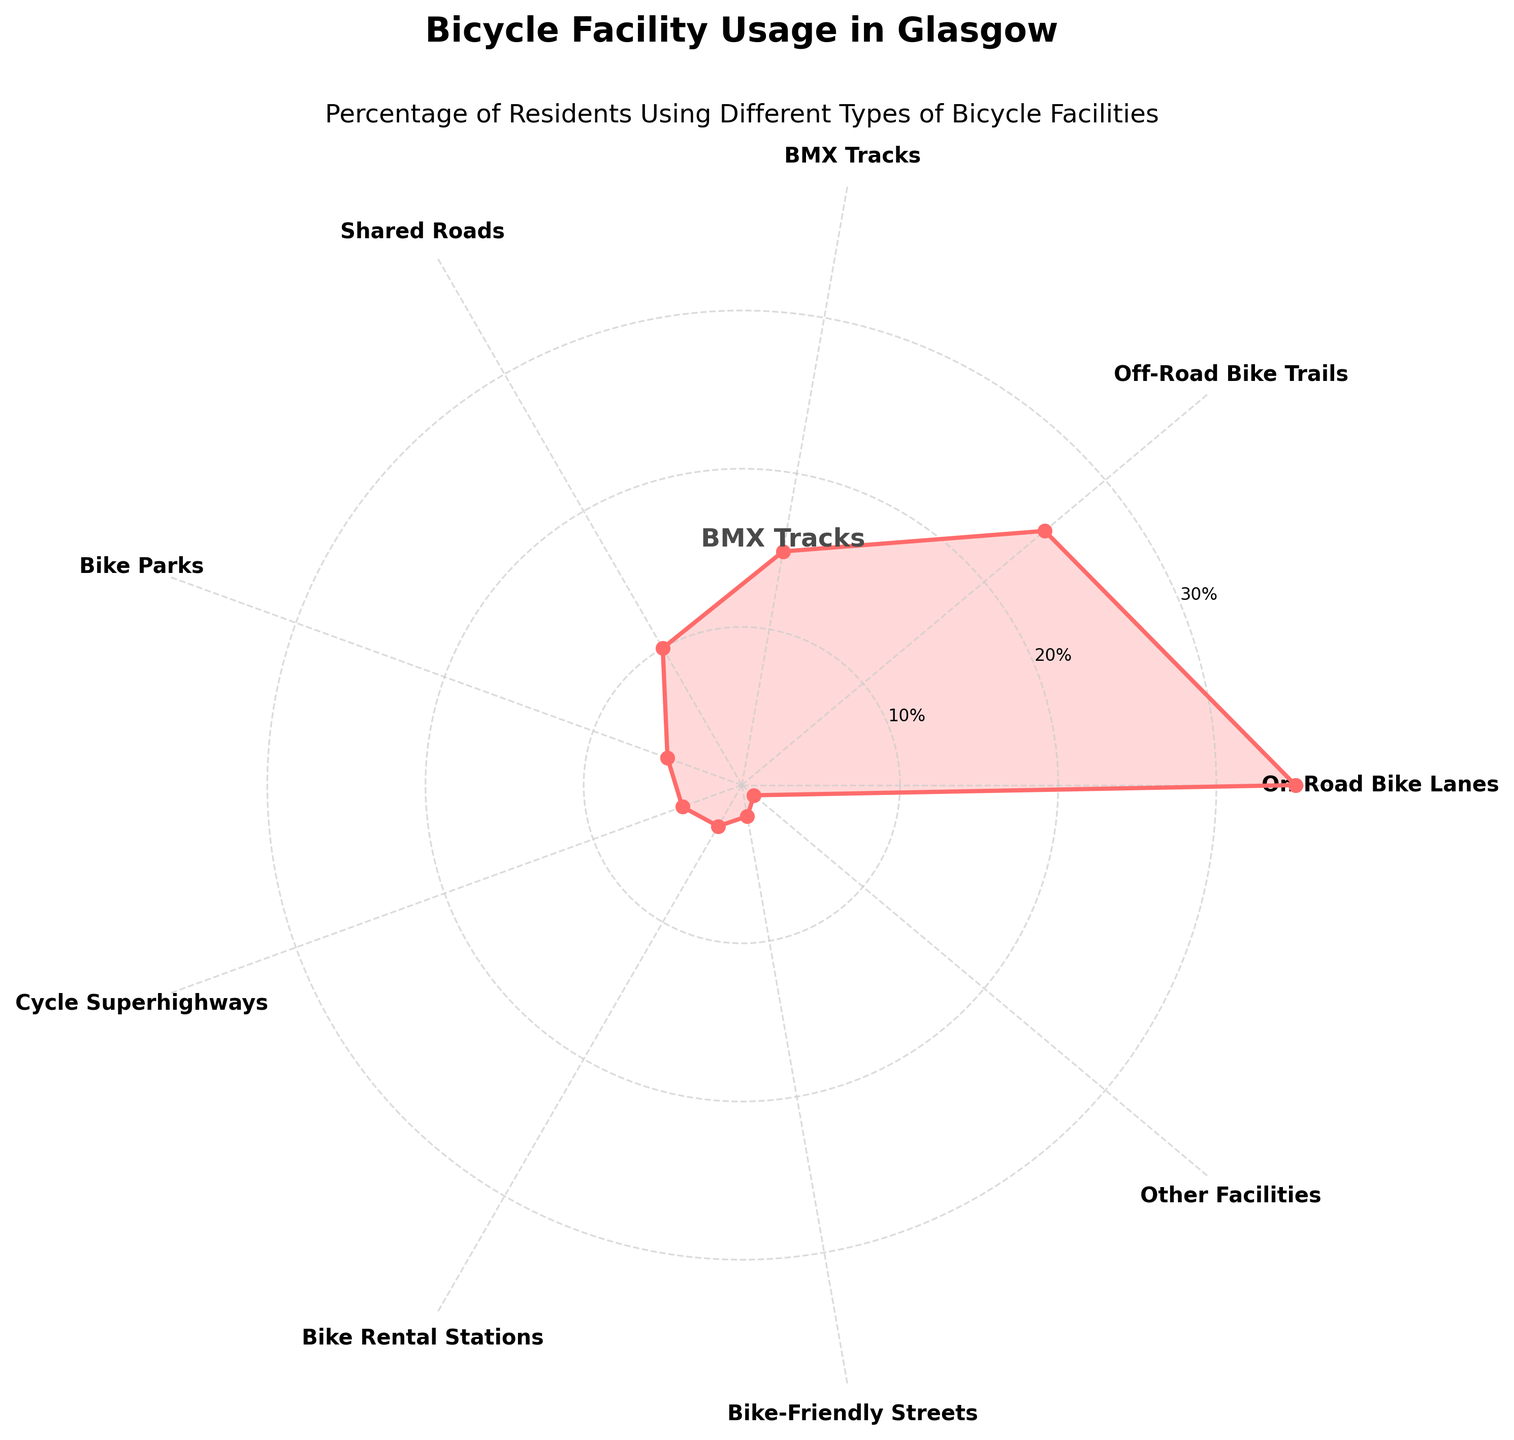What is the title of the figure? The title is usually located at the top of the chart. It describes the main subject of the visual representation.
Answer: Bicycle Facility Usage in Glasgow How many types of bicycle facilities are included in the figure? The categories are labeled along the outer circle. By counting these labels, we can determine the number of types.
Answer: 9 Which type of bicycle facility has the highest percentage of usage? By looking at the values around the circle and identifying the maximum one, we can find the facility with the highest percentage.
Answer: On-Road Bike Lanes What is the usage percentage of BMX Tracks? The BMX Tracks percentage is highlighted on the chart. Identify the corresponding value in the figure.
Answer: 15% How does the usage percentage of Off-Road Bike Trails compare to Shared Roads? Identify the values for both facilities and compare them directly.
Answer: Off-Road Bike Trails are 15% higher than Shared Roads What is the total percentage for the three least used bicycle facilities? Identify the percentages for Bike Rental Stations, Bike-Friendly Streets, and Other Facilities. Sum these values: 3% + 2% + 1%.
Answer: 6% If you combine the percentages of Bike Parks and Cycle Superhighways, does it exceed the percentage of Off-Road Bike Trails? Sum the percentages: 5% + 4% and compare the result with 25%.
Answer: No, it is 9%, which is less than 25% Which facility has a usage percentage that is exactly 10%? Locate the value of 10% around the circle and identify the corresponding facility.
Answer: Shared Roads How much more popular are On-Road Bike Lanes compared to Cycle Superhighways? Subtract the percentage of Cycle Superhighways from that of On-Road Bike Lanes: 35% - 4%.
Answer: 31% List the facilities in order of descending usage percentage. Sort the facilities starting from the highest percentage to the lowest.
Answer: On-Road Bike Lanes, Off-Road Bike Trails, BMX Tracks, Shared Roads, Bike Parks, Cycle Superhighways, Bike Rental Stations, Bike-Friendly Streets, Other Facilities 